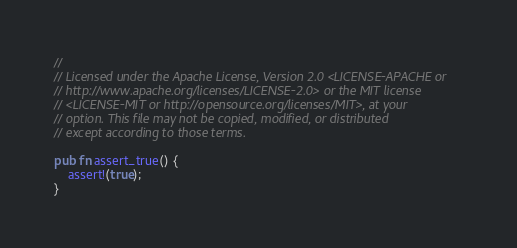Convert code to text. <code><loc_0><loc_0><loc_500><loc_500><_Rust_>//
// Licensed under the Apache License, Version 2.0 <LICENSE-APACHE or
// http://www.apache.org/licenses/LICENSE-2.0> or the MIT license
// <LICENSE-MIT or http://opensource.org/licenses/MIT>, at your
// option. This file may not be copied, modified, or distributed
// except according to those terms.

pub fn assert_true() {
    assert!(true);
}
</code> 